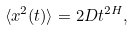<formula> <loc_0><loc_0><loc_500><loc_500>\langle x ^ { 2 } ( t ) \rangle = 2 D t ^ { 2 H } ,</formula> 